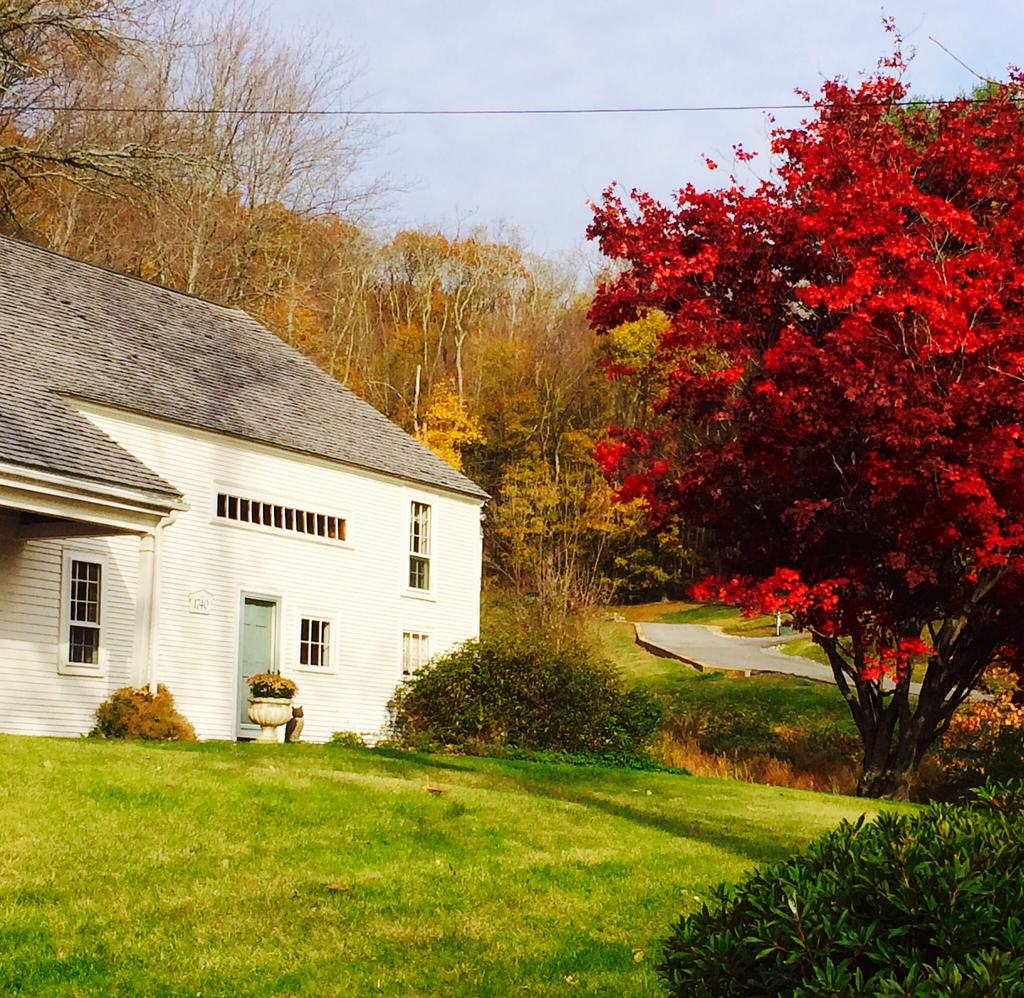What structure is the main subject of the image? There is a building in the image. What is located in front of the building? There is a potted plant and trees in front of the building. Can you describe the background of the image? There are trees and the sky visible in the background of the image. What type of rhythm can be heard coming from the building in the image? There is no indication of sound or rhythm in the image, as it only features a building, a potted plant, trees, and the sky. 